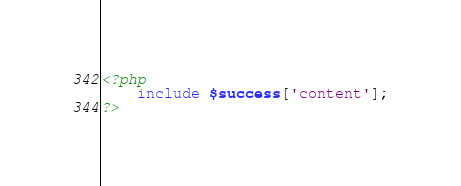<code> <loc_0><loc_0><loc_500><loc_500><_PHP_><?php
	include $success['content'];
?></code> 